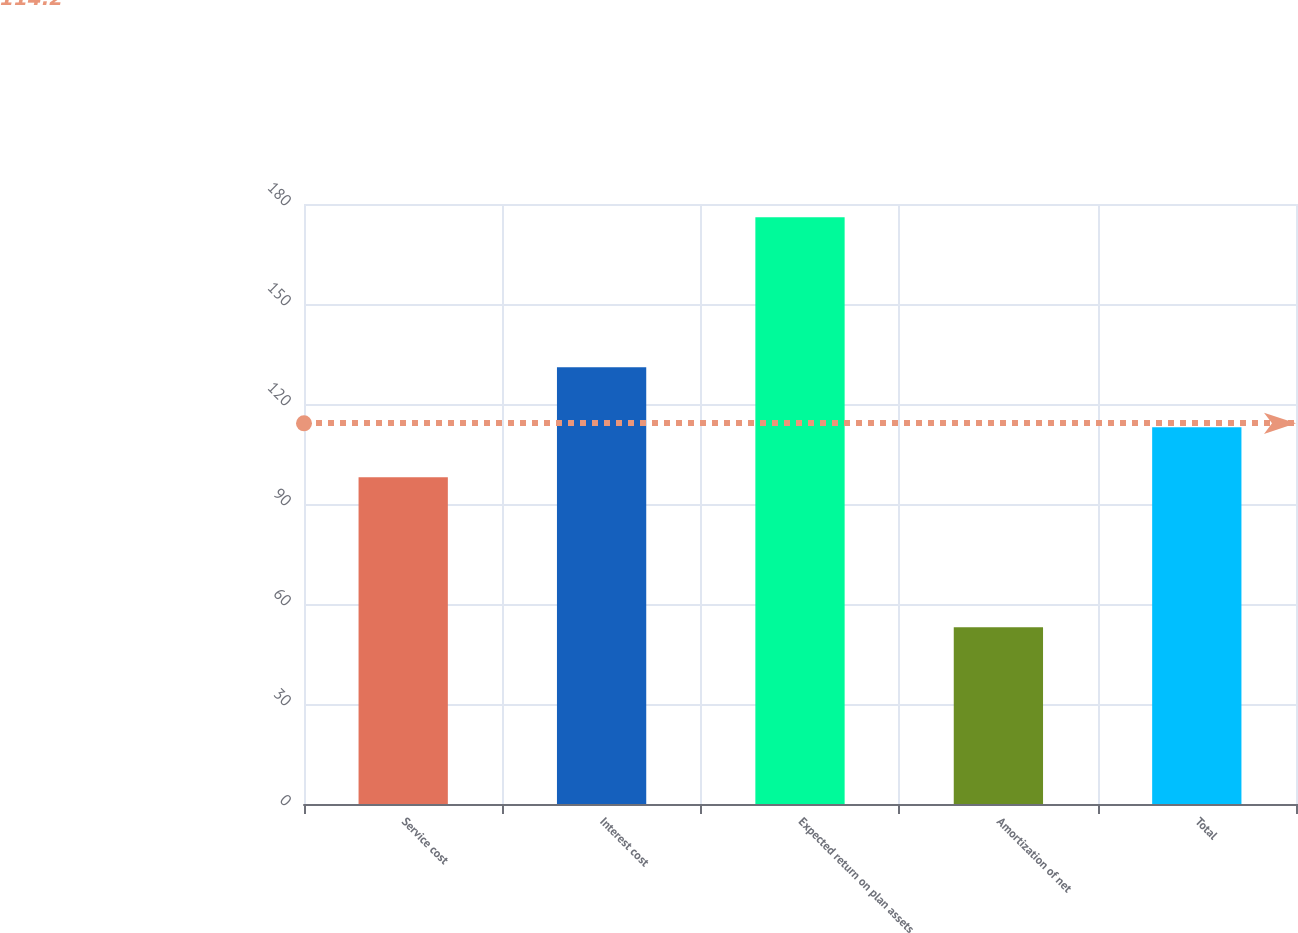Convert chart to OTSL. <chart><loc_0><loc_0><loc_500><loc_500><bar_chart><fcel>Service cost<fcel>Interest cost<fcel>Expected return on plan assets<fcel>Amortization of net<fcel>Total<nl><fcel>98<fcel>131<fcel>176<fcel>53<fcel>113<nl></chart> 